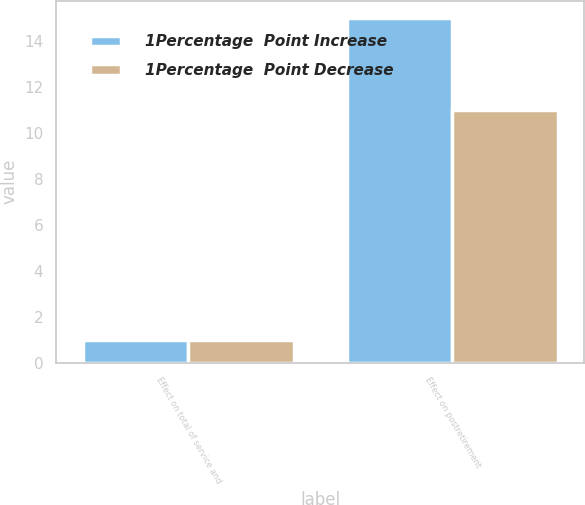Convert chart to OTSL. <chart><loc_0><loc_0><loc_500><loc_500><stacked_bar_chart><ecel><fcel>Effect on total of service and<fcel>Effect on postretirement<nl><fcel>1Percentage  Point Increase<fcel>1<fcel>15<nl><fcel>1Percentage  Point Decrease<fcel>1<fcel>11<nl></chart> 